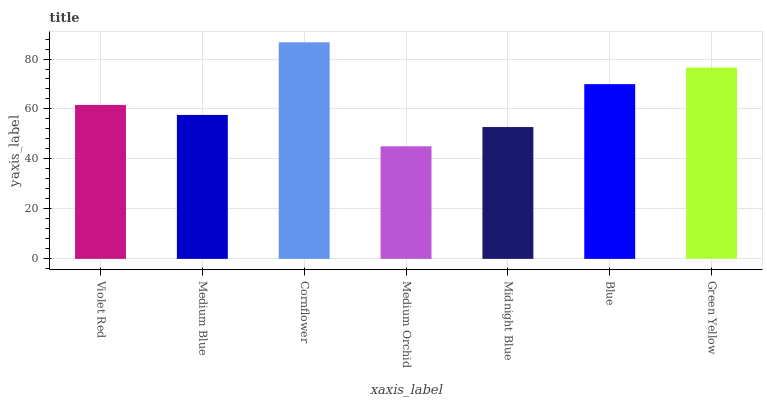Is Medium Blue the minimum?
Answer yes or no. No. Is Medium Blue the maximum?
Answer yes or no. No. Is Violet Red greater than Medium Blue?
Answer yes or no. Yes. Is Medium Blue less than Violet Red?
Answer yes or no. Yes. Is Medium Blue greater than Violet Red?
Answer yes or no. No. Is Violet Red less than Medium Blue?
Answer yes or no. No. Is Violet Red the high median?
Answer yes or no. Yes. Is Violet Red the low median?
Answer yes or no. Yes. Is Midnight Blue the high median?
Answer yes or no. No. Is Midnight Blue the low median?
Answer yes or no. No. 